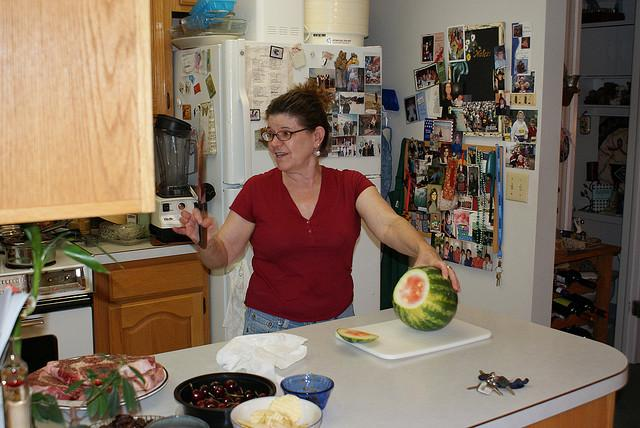What is the appliance next to the refrigerator? Please explain your reasoning. blender. There is a blender. 